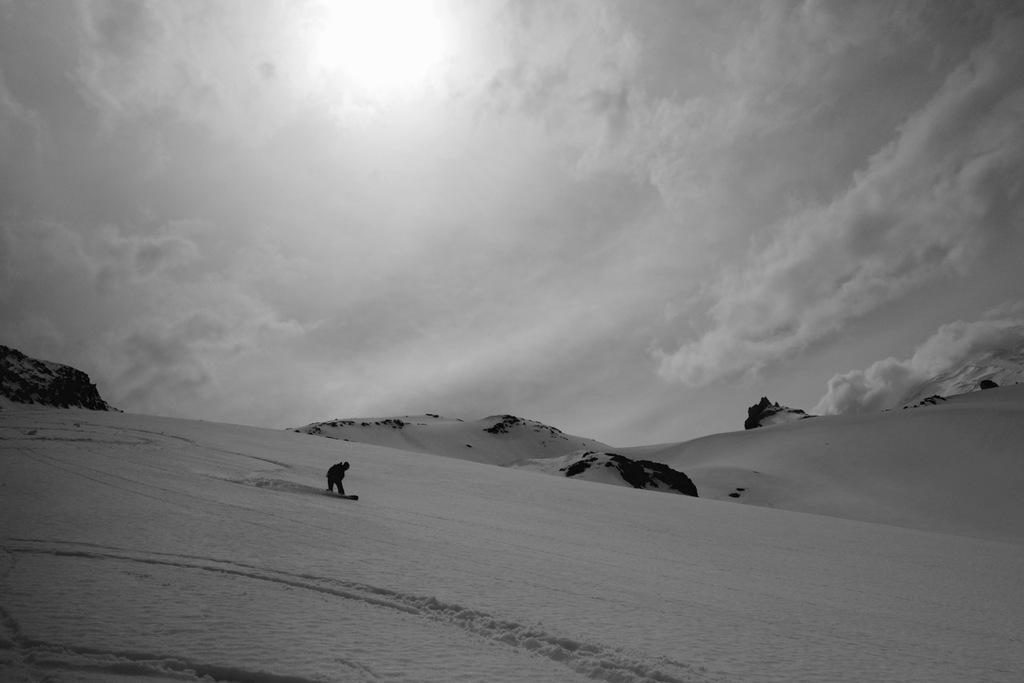Please provide a concise description of this image. In this image we can see a person skiing on the snow, there are some rocks and we can see clouded sky. 